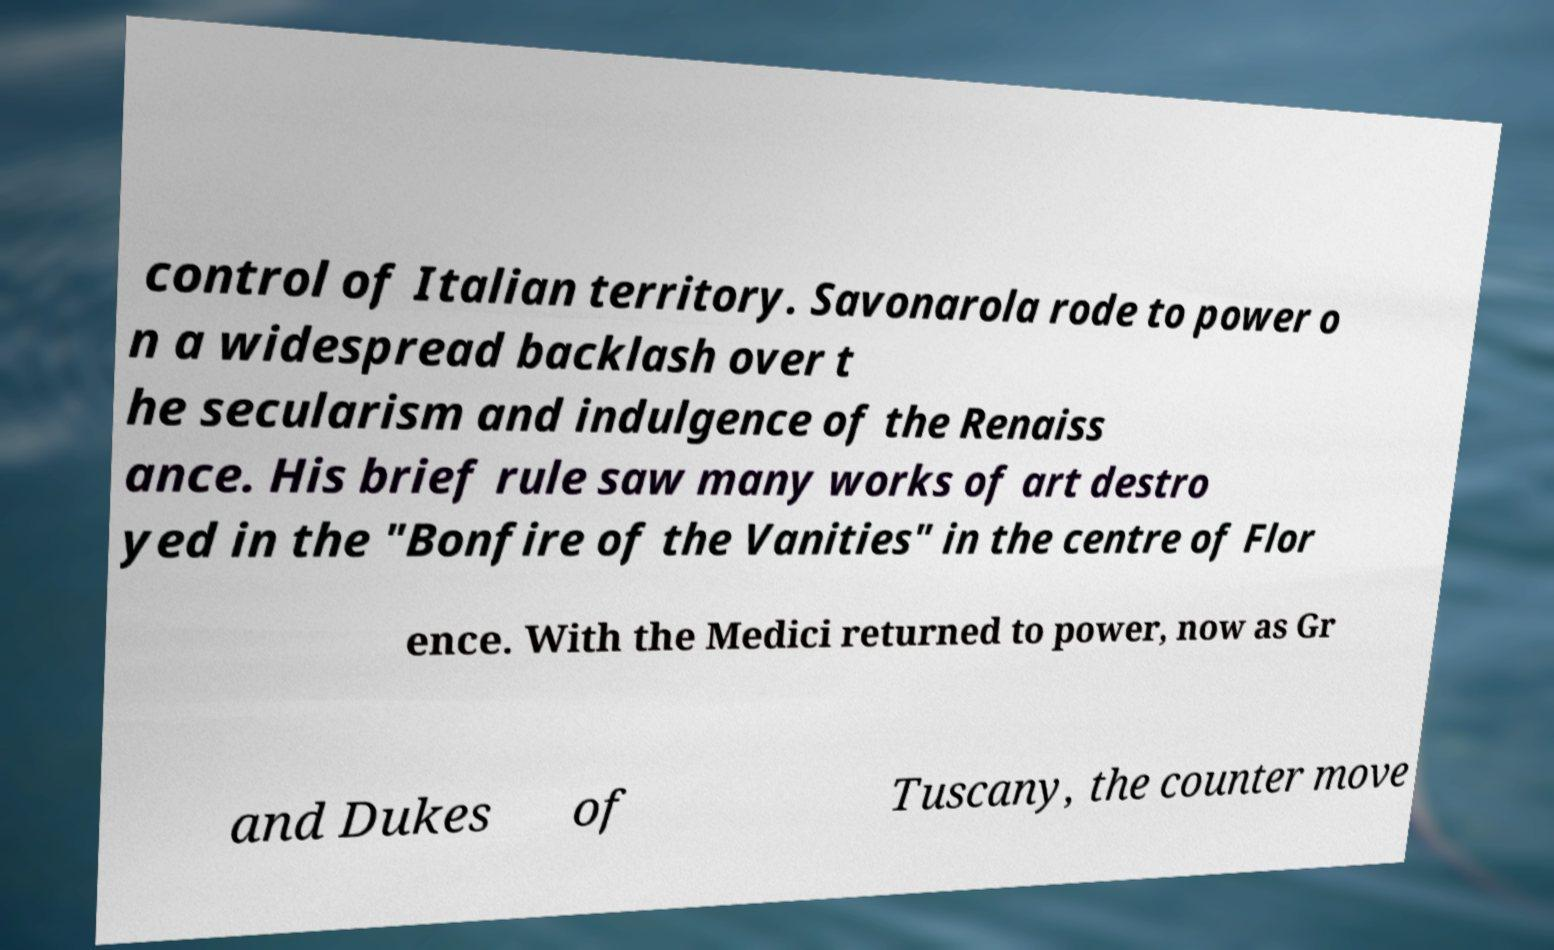Please identify and transcribe the text found in this image. control of Italian territory. Savonarola rode to power o n a widespread backlash over t he secularism and indulgence of the Renaiss ance. His brief rule saw many works of art destro yed in the "Bonfire of the Vanities" in the centre of Flor ence. With the Medici returned to power, now as Gr and Dukes of Tuscany, the counter move 